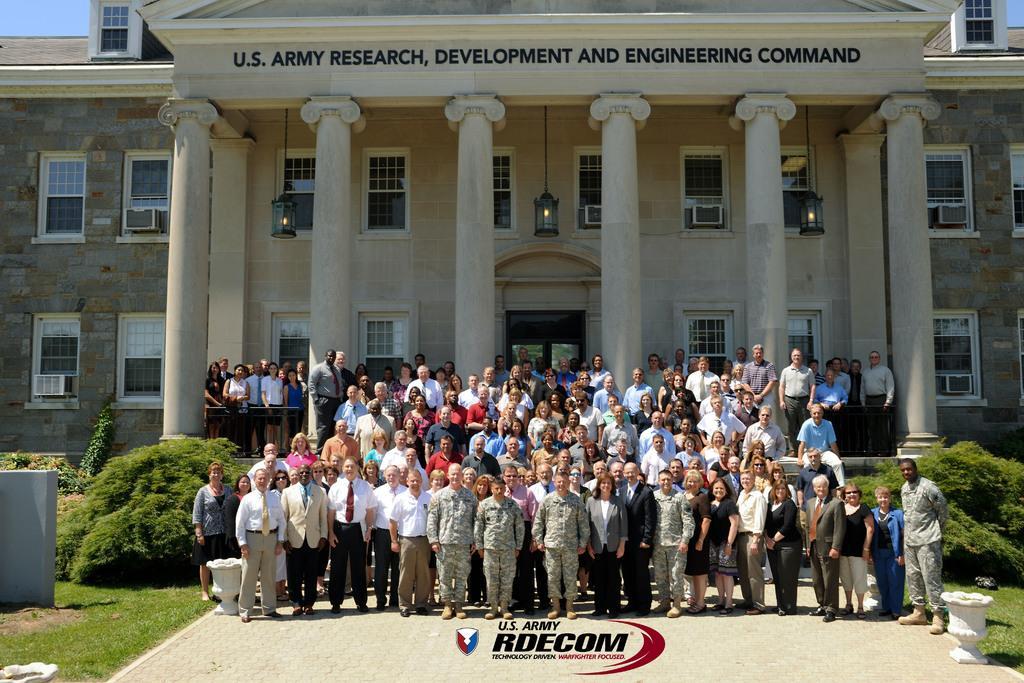In one or two sentences, can you explain what this image depicts? This is the picture of a building to which there are some windows, some lamps to the roof and in front of it there are some people standing and around there are some plants and trees. 